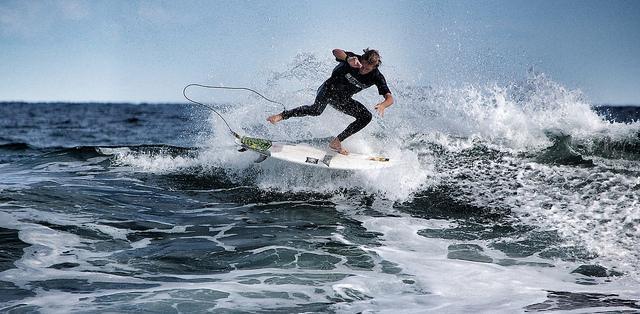How many surfboards can be seen?
Give a very brief answer. 1. 